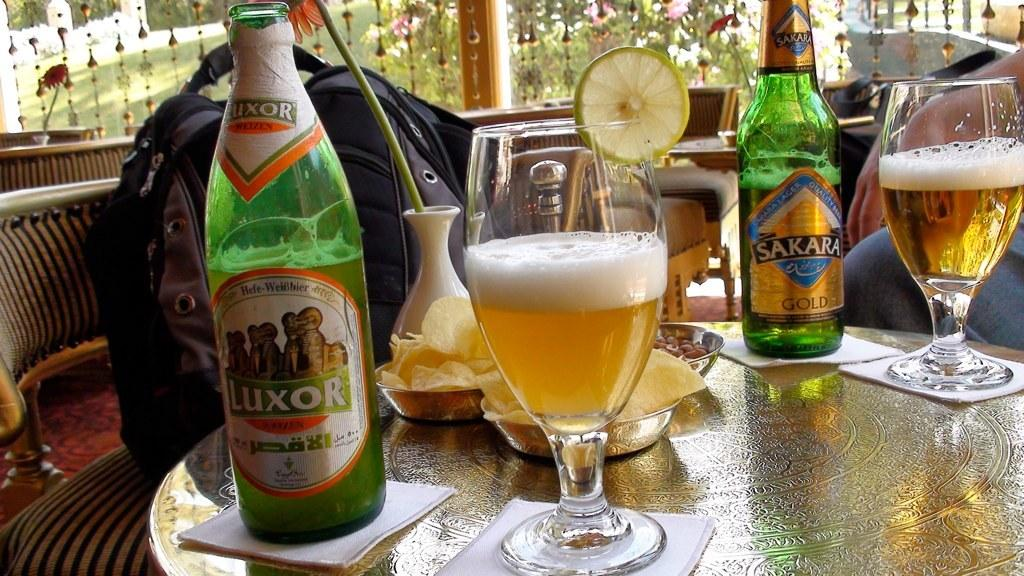<image>
Describe the image concisely. a bottle of luxor standing next to a glass of it 